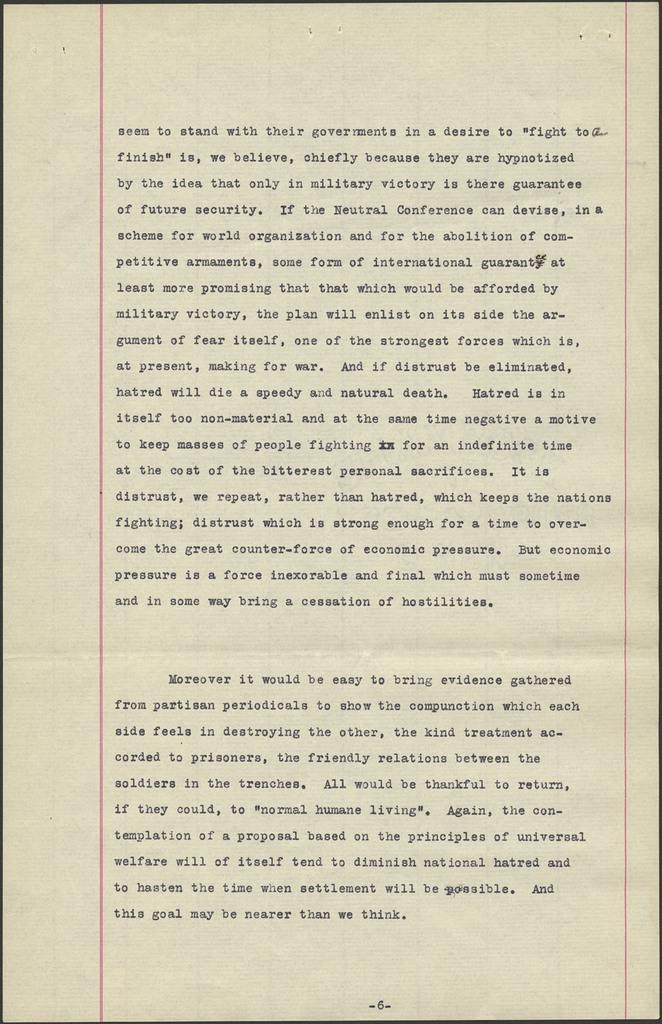What is the first word of the second paragraph?
Offer a very short reply. Moreover. What page number is this?
Provide a short and direct response. 6. 